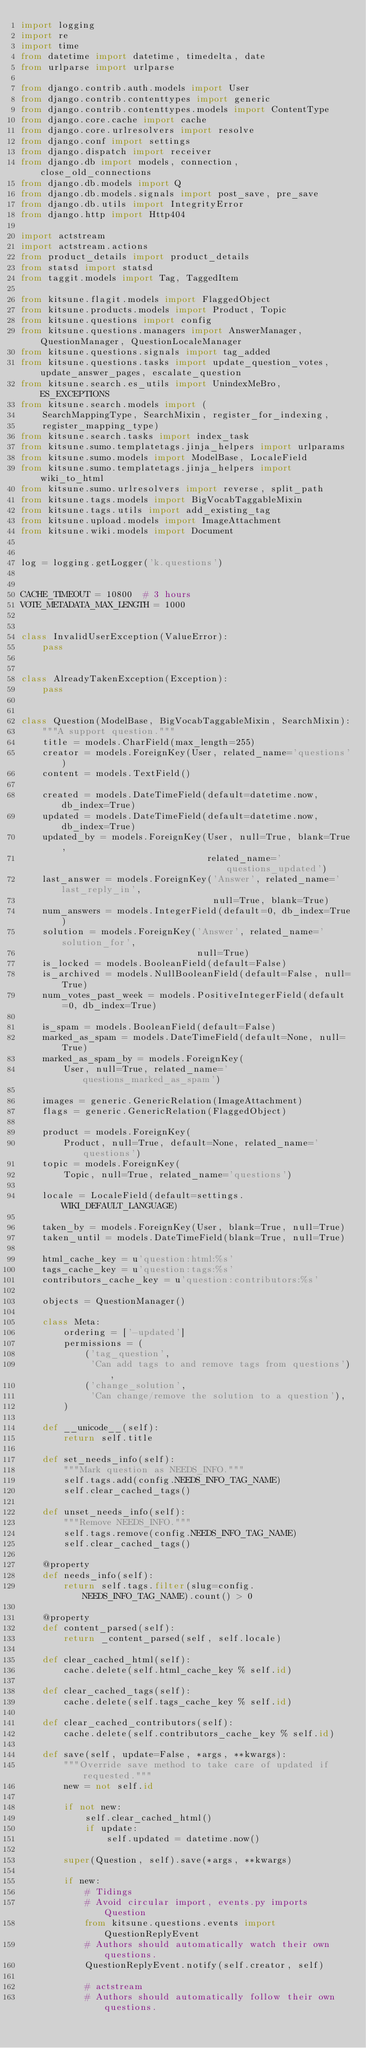Convert code to text. <code><loc_0><loc_0><loc_500><loc_500><_Python_>import logging
import re
import time
from datetime import datetime, timedelta, date
from urlparse import urlparse

from django.contrib.auth.models import User
from django.contrib.contenttypes import generic
from django.contrib.contenttypes.models import ContentType
from django.core.cache import cache
from django.core.urlresolvers import resolve
from django.conf import settings
from django.dispatch import receiver
from django.db import models, connection, close_old_connections
from django.db.models import Q
from django.db.models.signals import post_save, pre_save
from django.db.utils import IntegrityError
from django.http import Http404

import actstream
import actstream.actions
from product_details import product_details
from statsd import statsd
from taggit.models import Tag, TaggedItem

from kitsune.flagit.models import FlaggedObject
from kitsune.products.models import Product, Topic
from kitsune.questions import config
from kitsune.questions.managers import AnswerManager, QuestionManager, QuestionLocaleManager
from kitsune.questions.signals import tag_added
from kitsune.questions.tasks import update_question_votes, update_answer_pages, escalate_question
from kitsune.search.es_utils import UnindexMeBro, ES_EXCEPTIONS
from kitsune.search.models import (
    SearchMappingType, SearchMixin, register_for_indexing,
    register_mapping_type)
from kitsune.search.tasks import index_task
from kitsune.sumo.templatetags.jinja_helpers import urlparams
from kitsune.sumo.models import ModelBase, LocaleField
from kitsune.sumo.templatetags.jinja_helpers import wiki_to_html
from kitsune.sumo.urlresolvers import reverse, split_path
from kitsune.tags.models import BigVocabTaggableMixin
from kitsune.tags.utils import add_existing_tag
from kitsune.upload.models import ImageAttachment
from kitsune.wiki.models import Document


log = logging.getLogger('k.questions')


CACHE_TIMEOUT = 10800  # 3 hours
VOTE_METADATA_MAX_LENGTH = 1000


class InvalidUserException(ValueError):
    pass


class AlreadyTakenException(Exception):
    pass


class Question(ModelBase, BigVocabTaggableMixin, SearchMixin):
    """A support question."""
    title = models.CharField(max_length=255)
    creator = models.ForeignKey(User, related_name='questions')
    content = models.TextField()

    created = models.DateTimeField(default=datetime.now, db_index=True)
    updated = models.DateTimeField(default=datetime.now, db_index=True)
    updated_by = models.ForeignKey(User, null=True, blank=True,
                                   related_name='questions_updated')
    last_answer = models.ForeignKey('Answer', related_name='last_reply_in',
                                    null=True, blank=True)
    num_answers = models.IntegerField(default=0, db_index=True)
    solution = models.ForeignKey('Answer', related_name='solution_for',
                                 null=True)
    is_locked = models.BooleanField(default=False)
    is_archived = models.NullBooleanField(default=False, null=True)
    num_votes_past_week = models.PositiveIntegerField(default=0, db_index=True)

    is_spam = models.BooleanField(default=False)
    marked_as_spam = models.DateTimeField(default=None, null=True)
    marked_as_spam_by = models.ForeignKey(
        User, null=True, related_name='questions_marked_as_spam')

    images = generic.GenericRelation(ImageAttachment)
    flags = generic.GenericRelation(FlaggedObject)

    product = models.ForeignKey(
        Product, null=True, default=None, related_name='questions')
    topic = models.ForeignKey(
        Topic, null=True, related_name='questions')

    locale = LocaleField(default=settings.WIKI_DEFAULT_LANGUAGE)

    taken_by = models.ForeignKey(User, blank=True, null=True)
    taken_until = models.DateTimeField(blank=True, null=True)

    html_cache_key = u'question:html:%s'
    tags_cache_key = u'question:tags:%s'
    contributors_cache_key = u'question:contributors:%s'

    objects = QuestionManager()

    class Meta:
        ordering = ['-updated']
        permissions = (
            ('tag_question',
             'Can add tags to and remove tags from questions'),
            ('change_solution',
             'Can change/remove the solution to a question'),
        )

    def __unicode__(self):
        return self.title

    def set_needs_info(self):
        """Mark question as NEEDS_INFO."""
        self.tags.add(config.NEEDS_INFO_TAG_NAME)
        self.clear_cached_tags()

    def unset_needs_info(self):
        """Remove NEEDS_INFO."""
        self.tags.remove(config.NEEDS_INFO_TAG_NAME)
        self.clear_cached_tags()

    @property
    def needs_info(self):
        return self.tags.filter(slug=config.NEEDS_INFO_TAG_NAME).count() > 0

    @property
    def content_parsed(self):
        return _content_parsed(self, self.locale)

    def clear_cached_html(self):
        cache.delete(self.html_cache_key % self.id)

    def clear_cached_tags(self):
        cache.delete(self.tags_cache_key % self.id)

    def clear_cached_contributors(self):
        cache.delete(self.contributors_cache_key % self.id)

    def save(self, update=False, *args, **kwargs):
        """Override save method to take care of updated if requested."""
        new = not self.id

        if not new:
            self.clear_cached_html()
            if update:
                self.updated = datetime.now()

        super(Question, self).save(*args, **kwargs)

        if new:
            # Tidings
            # Avoid circular import, events.py imports Question
            from kitsune.questions.events import QuestionReplyEvent
            # Authors should automatically watch their own questions.
            QuestionReplyEvent.notify(self.creator, self)

            # actstream
            # Authors should automatically follow their own questions.</code> 